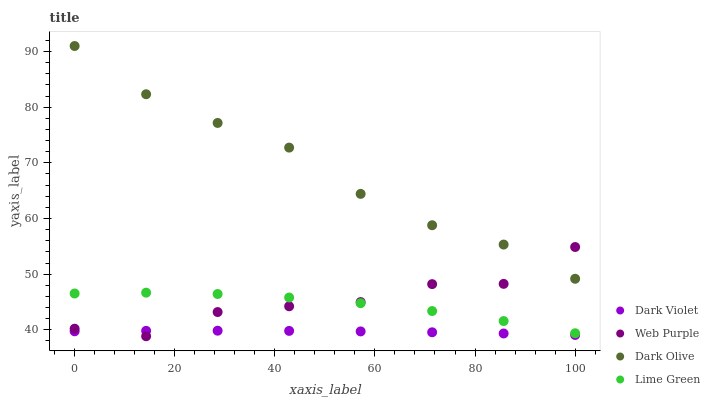Does Dark Violet have the minimum area under the curve?
Answer yes or no. Yes. Does Dark Olive have the maximum area under the curve?
Answer yes or no. Yes. Does Lime Green have the minimum area under the curve?
Answer yes or no. No. Does Lime Green have the maximum area under the curve?
Answer yes or no. No. Is Dark Violet the smoothest?
Answer yes or no. Yes. Is Web Purple the roughest?
Answer yes or no. Yes. Is Dark Olive the smoothest?
Answer yes or no. No. Is Dark Olive the roughest?
Answer yes or no. No. Does Web Purple have the lowest value?
Answer yes or no. Yes. Does Lime Green have the lowest value?
Answer yes or no. No. Does Dark Olive have the highest value?
Answer yes or no. Yes. Does Lime Green have the highest value?
Answer yes or no. No. Is Dark Violet less than Lime Green?
Answer yes or no. Yes. Is Dark Olive greater than Dark Violet?
Answer yes or no. Yes. Does Web Purple intersect Lime Green?
Answer yes or no. Yes. Is Web Purple less than Lime Green?
Answer yes or no. No. Is Web Purple greater than Lime Green?
Answer yes or no. No. Does Dark Violet intersect Lime Green?
Answer yes or no. No. 